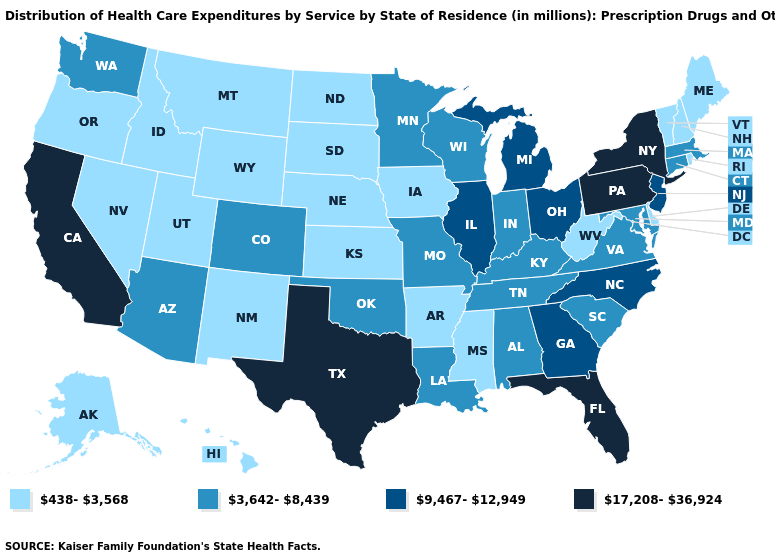Does the map have missing data?
Give a very brief answer. No. Does Massachusetts have the lowest value in the USA?
Keep it brief. No. Name the states that have a value in the range 438-3,568?
Keep it brief. Alaska, Arkansas, Delaware, Hawaii, Idaho, Iowa, Kansas, Maine, Mississippi, Montana, Nebraska, Nevada, New Hampshire, New Mexico, North Dakota, Oregon, Rhode Island, South Dakota, Utah, Vermont, West Virginia, Wyoming. Does the map have missing data?
Be succinct. No. What is the highest value in the USA?
Give a very brief answer. 17,208-36,924. What is the value of South Dakota?
Concise answer only. 438-3,568. Does the map have missing data?
Concise answer only. No. What is the lowest value in the South?
Quick response, please. 438-3,568. Name the states that have a value in the range 17,208-36,924?
Answer briefly. California, Florida, New York, Pennsylvania, Texas. Does New York have the highest value in the USA?
Give a very brief answer. Yes. Name the states that have a value in the range 438-3,568?
Write a very short answer. Alaska, Arkansas, Delaware, Hawaii, Idaho, Iowa, Kansas, Maine, Mississippi, Montana, Nebraska, Nevada, New Hampshire, New Mexico, North Dakota, Oregon, Rhode Island, South Dakota, Utah, Vermont, West Virginia, Wyoming. Does the map have missing data?
Be succinct. No. Name the states that have a value in the range 438-3,568?
Concise answer only. Alaska, Arkansas, Delaware, Hawaii, Idaho, Iowa, Kansas, Maine, Mississippi, Montana, Nebraska, Nevada, New Hampshire, New Mexico, North Dakota, Oregon, Rhode Island, South Dakota, Utah, Vermont, West Virginia, Wyoming. Name the states that have a value in the range 9,467-12,949?
Answer briefly. Georgia, Illinois, Michigan, New Jersey, North Carolina, Ohio. Name the states that have a value in the range 3,642-8,439?
Concise answer only. Alabama, Arizona, Colorado, Connecticut, Indiana, Kentucky, Louisiana, Maryland, Massachusetts, Minnesota, Missouri, Oklahoma, South Carolina, Tennessee, Virginia, Washington, Wisconsin. 